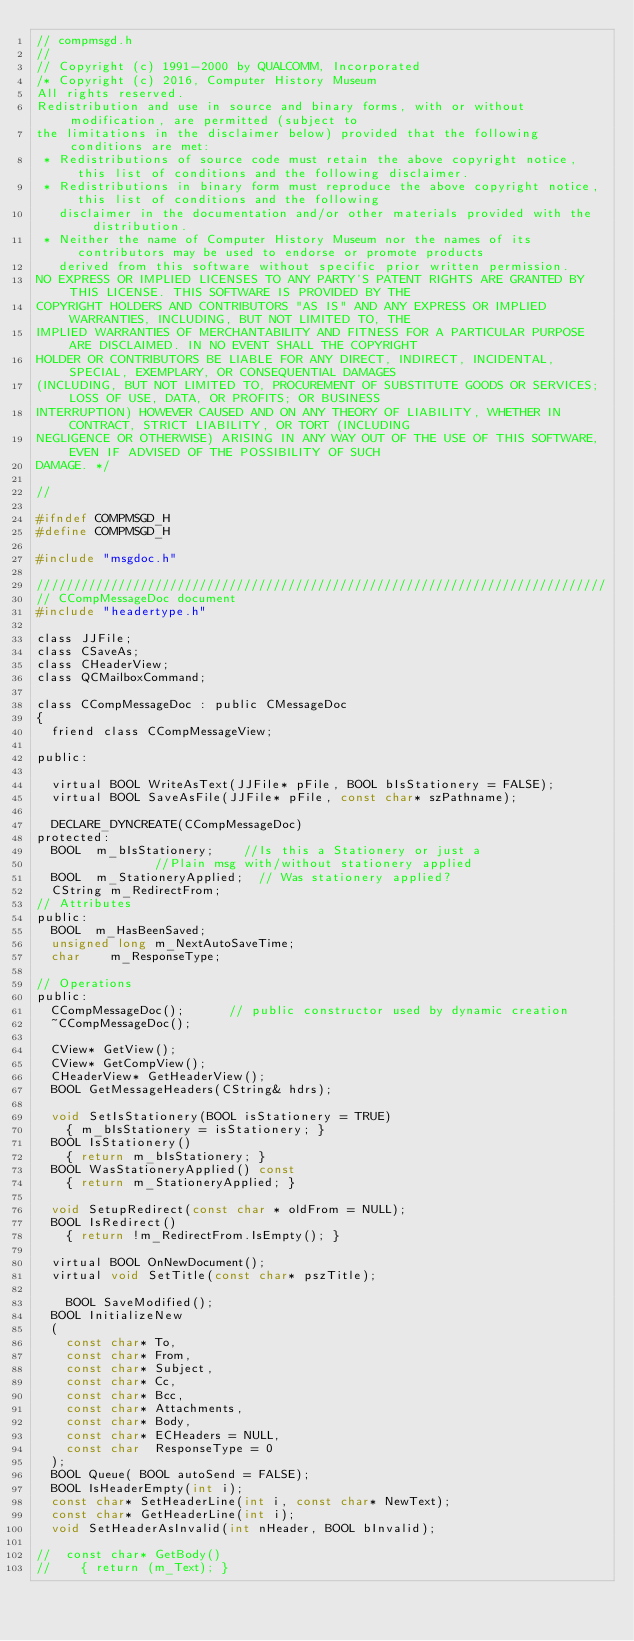Convert code to text. <code><loc_0><loc_0><loc_500><loc_500><_C_>// compmsgd.h
//
// Copyright (c) 1991-2000 by QUALCOMM, Incorporated
/* Copyright (c) 2016, Computer History Museum 
All rights reserved. 
Redistribution and use in source and binary forms, with or without modification, are permitted (subject to 
the limitations in the disclaimer below) provided that the following conditions are met: 
 * Redistributions of source code must retain the above copyright notice, this list of conditions and the following disclaimer. 
 * Redistributions in binary form must reproduce the above copyright notice, this list of conditions and the following 
   disclaimer in the documentation and/or other materials provided with the distribution. 
 * Neither the name of Computer History Museum nor the names of its contributors may be used to endorse or promote products 
   derived from this software without specific prior written permission. 
NO EXPRESS OR IMPLIED LICENSES TO ANY PARTY'S PATENT RIGHTS ARE GRANTED BY THIS LICENSE. THIS SOFTWARE IS PROVIDED BY THE 
COPYRIGHT HOLDERS AND CONTRIBUTORS "AS IS" AND ANY EXPRESS OR IMPLIED WARRANTIES, INCLUDING, BUT NOT LIMITED TO, THE 
IMPLIED WARRANTIES OF MERCHANTABILITY AND FITNESS FOR A PARTICULAR PURPOSE ARE DISCLAIMED. IN NO EVENT SHALL THE COPYRIGHT 
HOLDER OR CONTRIBUTORS BE LIABLE FOR ANY DIRECT, INDIRECT, INCIDENTAL, SPECIAL, EXEMPLARY, OR CONSEQUENTIAL DAMAGES 
(INCLUDING, BUT NOT LIMITED TO, PROCUREMENT OF SUBSTITUTE GOODS OR SERVICES; LOSS OF USE, DATA, OR PROFITS; OR BUSINESS 
INTERRUPTION) HOWEVER CAUSED AND ON ANY THEORY OF LIABILITY, WHETHER IN CONTRACT, STRICT LIABILITY, OR TORT (INCLUDING 
NEGLIGENCE OR OTHERWISE) ARISING IN ANY WAY OUT OF THE USE OF THIS SOFTWARE, EVEN IF ADVISED OF THE POSSIBILITY OF SUCH 
DAMAGE. */

//

#ifndef COMPMSGD_H
#define COMPMSGD_H

#include "msgdoc.h"

/////////////////////////////////////////////////////////////////////////////
// CCompMessageDoc document
#include "headertype.h"

class JJFile;
class CSaveAs;
class CHeaderView;
class QCMailboxCommand;

class CCompMessageDoc : public CMessageDoc
{
	friend class CCompMessageView;

public:

	virtual BOOL WriteAsText(JJFile* pFile, BOOL bIsStationery = FALSE);
	virtual BOOL SaveAsFile(JJFile* pFile, const char* szPathname);
	
	DECLARE_DYNCREATE(CCompMessageDoc)
protected:
	BOOL	m_bIsStationery;		//Is this a Stationery or just a 
								//Plain msg with/without stationery applied
	BOOL	m_StationeryApplied;	// Was stationery applied?
	CString	m_RedirectFrom;
// Attributes
public:
	BOOL	m_HasBeenSaved;
	unsigned long m_NextAutoSaveTime;
	char    m_ResponseType;

// Operations
public:
	CCompMessageDoc();			// public constructor used by dynamic creation
	~CCompMessageDoc();
	
	CView* GetView();
	CView* GetCompView();
	CHeaderView* GetHeaderView();
	BOOL GetMessageHeaders(CString& hdrs);

	void SetIsStationery(BOOL isStationery = TRUE)
		{ m_bIsStationery = isStationery; }
	BOOL IsStationery()
		{ return m_bIsStationery; }
	BOOL WasStationeryApplied() const
		{ return m_StationeryApplied; }

	void SetupRedirect(const char * oldFrom = NULL);
	BOOL IsRedirect()
		{ return !m_RedirectFrom.IsEmpty(); }

	virtual BOOL OnNewDocument();
	virtual void SetTitle(const char* pszTitle);

    BOOL SaveModified();
	BOOL InitializeNew
	(
		const char* To, 
		const char* From, 
		const char* Subject, 
		const char* Cc,
		const char* Bcc, 
		const char* Attachments, 
		const char* Body,
		const char* ECHeaders = NULL,
		const char  ResponseType = 0
	);
	BOOL Queue( BOOL autoSend = FALSE);
	BOOL IsHeaderEmpty(int i);
	const char* SetHeaderLine(int i, const char* NewText);
	const char* GetHeaderLine(int i);
	void SetHeaderAsInvalid(int nHeader, BOOL bInvalid);

//	const char* GetBody()   
//		{ return (m_Text); }</code> 